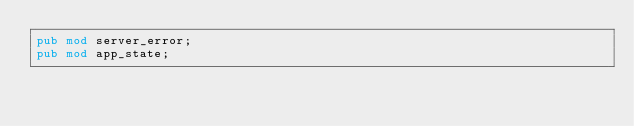<code> <loc_0><loc_0><loc_500><loc_500><_Rust_>pub mod server_error;
pub mod app_state;</code> 